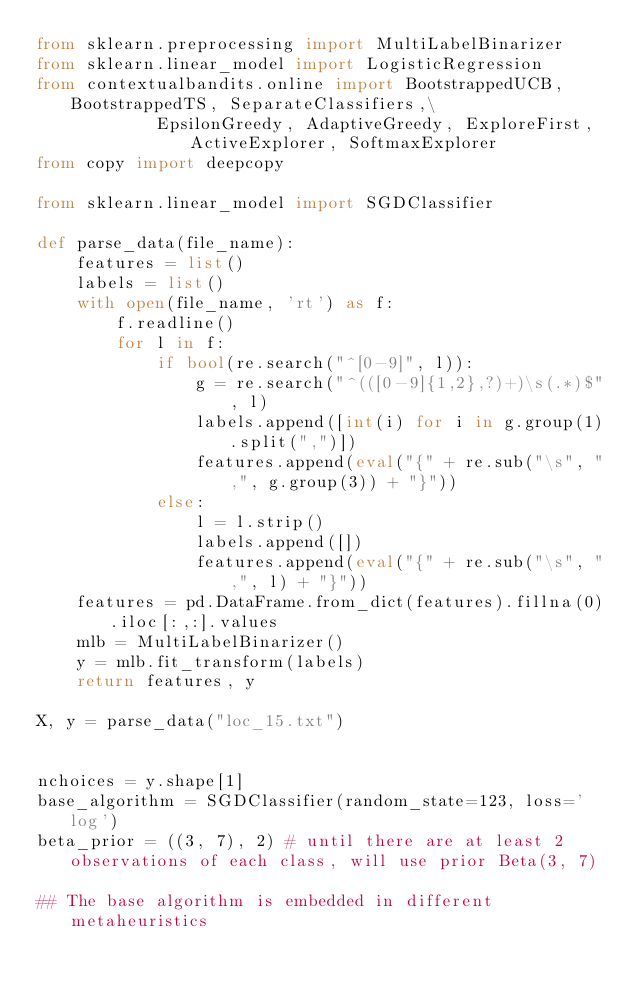Convert code to text. <code><loc_0><loc_0><loc_500><loc_500><_Python_>from sklearn.preprocessing import MultiLabelBinarizer
from sklearn.linear_model import LogisticRegression
from contextualbandits.online import BootstrappedUCB, BootstrappedTS, SeparateClassifiers,\
            EpsilonGreedy, AdaptiveGreedy, ExploreFirst, ActiveExplorer, SoftmaxExplorer
from copy import deepcopy

from sklearn.linear_model import SGDClassifier

def parse_data(file_name):
    features = list()
    labels = list()
    with open(file_name, 'rt') as f:
        f.readline()
        for l in f:
            if bool(re.search("^[0-9]", l)):
                g = re.search("^(([0-9]{1,2},?)+)\s(.*)$", l)
                labels.append([int(i) for i in g.group(1).split(",")])
                features.append(eval("{" + re.sub("\s", ",", g.group(3)) + "}"))
            else:
                l = l.strip()
                labels.append([])
                features.append(eval("{" + re.sub("\s", ",", l) + "}"))
    features = pd.DataFrame.from_dict(features).fillna(0).iloc[:,:].values
    mlb = MultiLabelBinarizer()
    y = mlb.fit_transform(labels)
    return features, y

X, y = parse_data("loc_15.txt")


nchoices = y.shape[1]
base_algorithm = SGDClassifier(random_state=123, loss='log')
beta_prior = ((3, 7), 2) # until there are at least 2 observations of each class, will use prior Beta(3, 7)

## The base algorithm is embedded in different metaheuristics</code> 